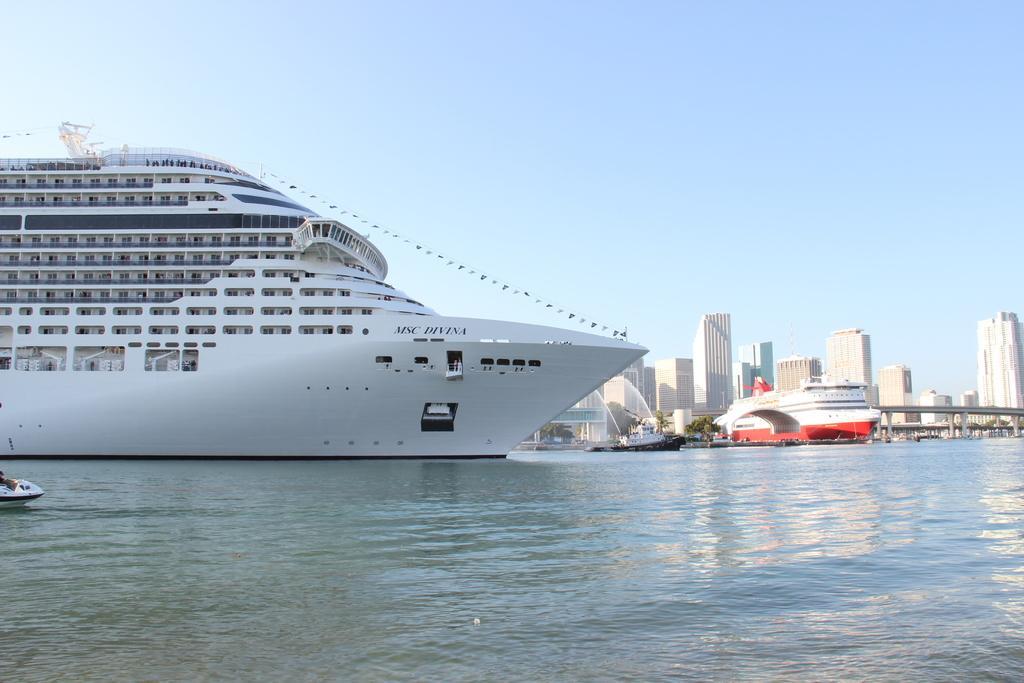Can you describe this image briefly? In the center of the image we can see ship, boats, buildings, bridge, trees. At the bottom of the image we can see the water. At the top of the image we can see the sky. 